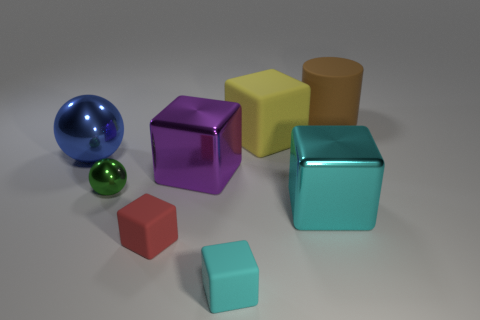What is the size of the object left of the shiny ball on the right side of the blue shiny thing?
Provide a short and direct response. Large. Is the number of cylinders greater than the number of yellow shiny cubes?
Your response must be concise. Yes. Are there more purple metallic objects that are on the right side of the tiny green sphere than small cyan cubes that are behind the large brown cylinder?
Provide a short and direct response. Yes. There is a object that is to the right of the blue thing and to the left of the red cube; how big is it?
Provide a succinct answer. Small. How many red things are the same size as the cyan metal block?
Offer a very short reply. 0. There is a metallic thing on the left side of the tiny shiny object; does it have the same shape as the large purple metal thing?
Your answer should be very brief. No. Are there fewer blue metallic spheres in front of the small cyan block than brown shiny spheres?
Your response must be concise. No. Is there a shiny object that has the same color as the big metal sphere?
Give a very brief answer. No. Do the purple metallic object and the large matte thing that is on the right side of the big rubber block have the same shape?
Keep it short and to the point. No. Are there any tiny cubes that have the same material as the blue thing?
Make the answer very short. No. 